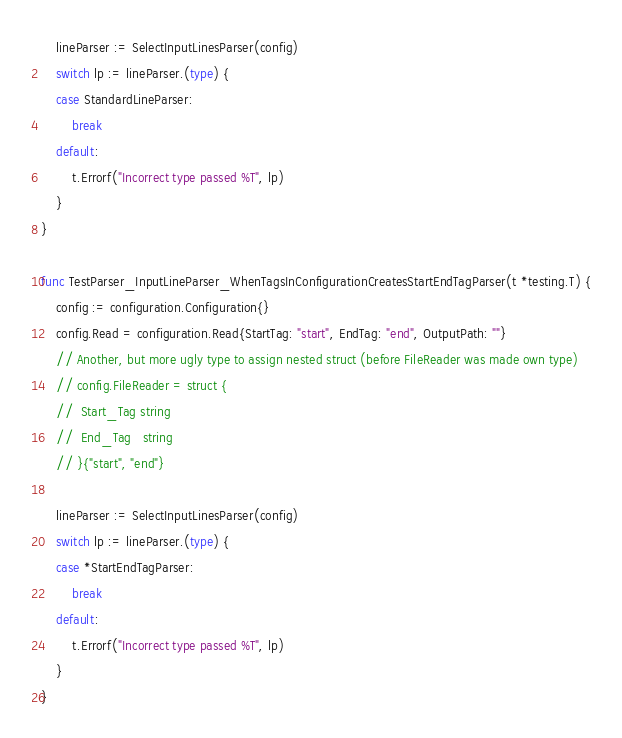<code> <loc_0><loc_0><loc_500><loc_500><_Go_>	lineParser := SelectInputLinesParser(config)
	switch lp := lineParser.(type) {
	case StandardLineParser:
		break
	default:
		t.Errorf("Incorrect type passed %T", lp)
	}
}

func TestParser_InputLineParser_WhenTagsInConfigurationCreatesStartEndTagParser(t *testing.T) {
	config := configuration.Configuration{}
	config.Read = configuration.Read{StartTag: "start", EndTag: "end", OutputPath: ""}
	// Another, but more ugly type to assign nested struct (before FileReader was made own type)
	// config.FileReader = struct {
	// 	Start_Tag string
	// 	End_Tag   string
	// }{"start", "end"}

	lineParser := SelectInputLinesParser(config)
	switch lp := lineParser.(type) {
	case *StartEndTagParser:
		break
	default:
		t.Errorf("Incorrect type passed %T", lp)
	}
}
</code> 